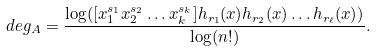Convert formula to latex. <formula><loc_0><loc_0><loc_500><loc_500>d e g _ { A } = \frac { \log ( [ x _ { 1 } ^ { s _ { 1 } } x _ { 2 } ^ { s _ { 2 } } \dots x _ { k } ^ { s _ { k } } ] h _ { r _ { 1 } } ( { x } ) h _ { r _ { 2 } } ( { x } ) \dots h _ { r _ { \ell } } ( { x } ) ) } { \log ( n ! ) } .</formula> 